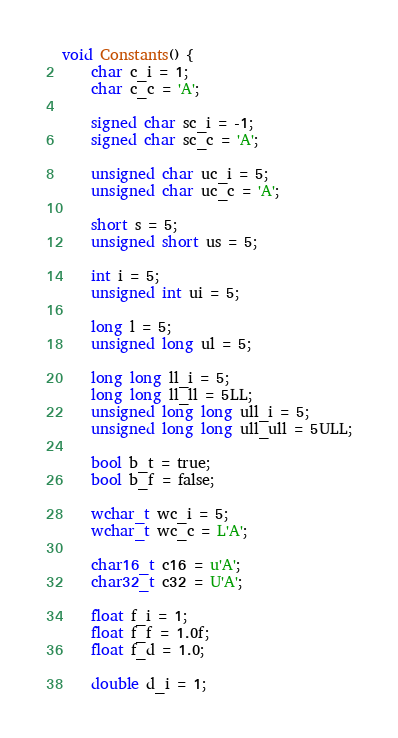Convert code to text. <code><loc_0><loc_0><loc_500><loc_500><_C++_>void Constants() {
    char c_i = 1;
    char c_c = 'A';

    signed char sc_i = -1;
    signed char sc_c = 'A';

    unsigned char uc_i = 5;
    unsigned char uc_c = 'A';

    short s = 5;
    unsigned short us = 5;

    int i = 5;
    unsigned int ui = 5;

    long l = 5;
    unsigned long ul = 5;

    long long ll_i = 5;
    long long ll_ll = 5LL;
    unsigned long long ull_i = 5;
    unsigned long long ull_ull = 5ULL;

    bool b_t = true;
    bool b_f = false;

    wchar_t wc_i = 5;
    wchar_t wc_c = L'A';

    char16_t c16 = u'A';
    char32_t c32 = U'A';

    float f_i = 1;
    float f_f = 1.0f;
    float f_d = 1.0;

    double d_i = 1;</code> 